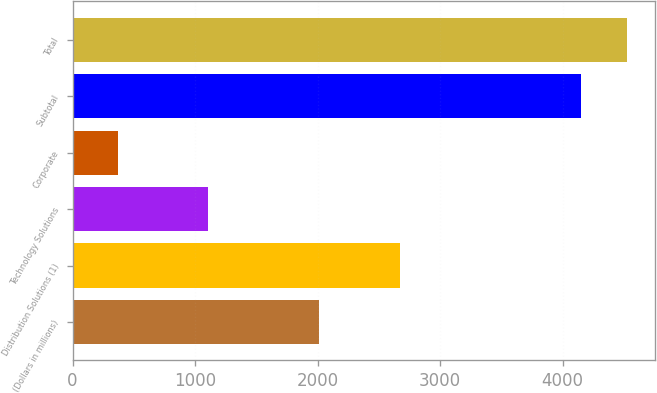Convert chart. <chart><loc_0><loc_0><loc_500><loc_500><bar_chart><fcel>(Dollars in millions)<fcel>Distribution Solutions (1)<fcel>Technology Solutions<fcel>Corporate<fcel>Subtotal<fcel>Total<nl><fcel>2011<fcel>2673<fcel>1108<fcel>368<fcel>4149<fcel>4527.1<nl></chart> 